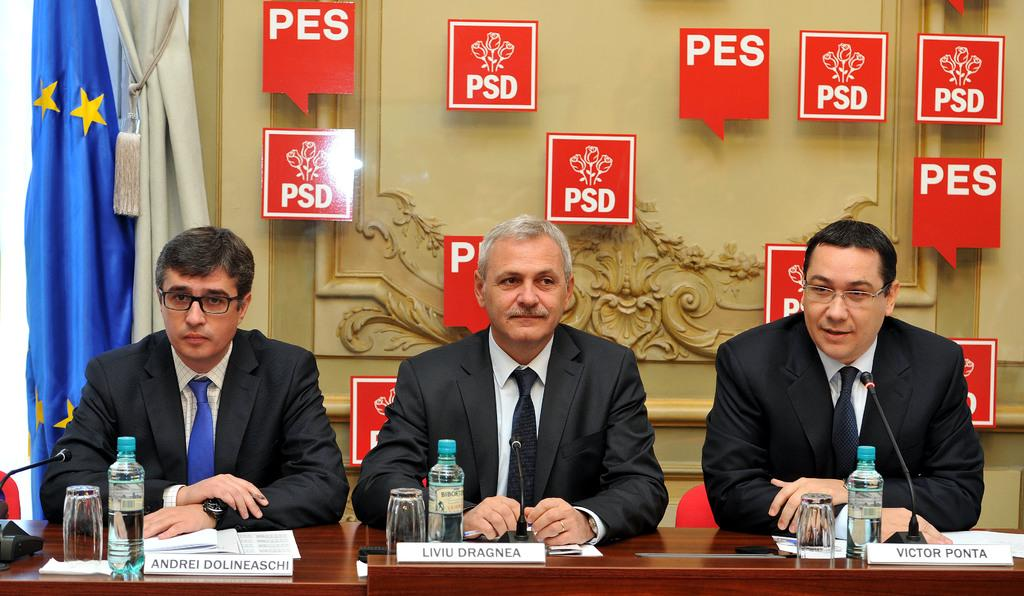What are the people in the image doing? There are persons sitting at the table in the image. What objects are on the table with the people? Name boards, water bottles, mics, and glass tumblers are on the table. What can be seen in the background of the image? There is a flag and a wall in the background. What type of reward is being given to the person in the image? There is no reward being given in the image; it only shows people sitting at a table with various objects. Can you tell me where the mailbox is located in the image? There is no mailbox present in the image. 